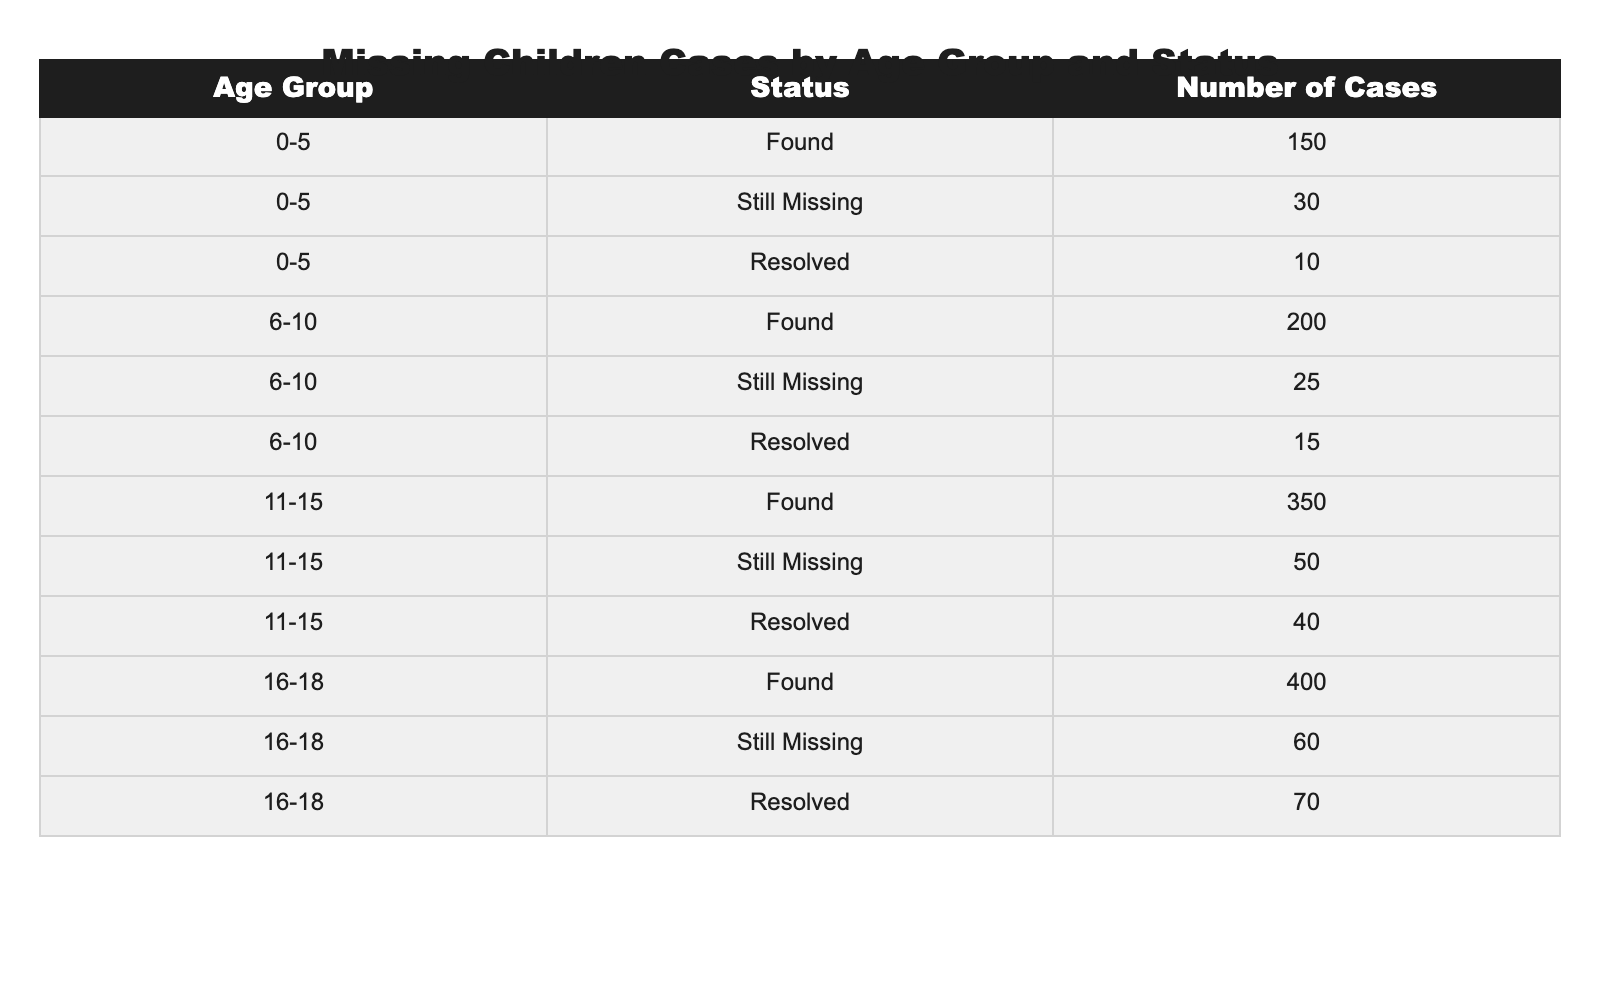What is the total number of missing children aged 0-5? To find this, I add the number of cases for the 'Still Missing' and 'Resolved' statuses for the 0-5 age group: 30 (Still Missing) + 10 (Resolved) = 40.
Answer: 40 How many children aged 11-15 are still missing? The table shows directly that there are 50 cases in the 'Still Missing' status for the 11-15 age group.
Answer: 50 What is the total number of found cases across all age groups? I add the number of cases for the 'Found' status in each age group: 150 (0-5) + 200 (6-10) + 350 (11-15) + 400 (16-18) = 1100.
Answer: 1100 Are there more found cases or missing cases in the age group 6-10? I compare the 'Found' cases (200) with the 'Still Missing' cases (25) in the 6-10 age group. Since 200 is greater than 25, there are more found cases.
Answer: Yes What is the average number of resolved cases across all age groups? I first find the total resolved cases: 10 (0-5) + 15 (6-10) + 40 (11-15) + 70 (16-18) = 135. There are 4 age groups, so the average is 135 / 4 = 33.75.
Answer: 33.75 Which age group has the highest number of still missing cases? The table shows: 30 (0-5), 25 (6-10), 50 (11-15), and 60 (16-18). The age group 16-18 has the highest with 60.
Answer: 16-18 How many more resolved cases are there in the 16-18 age group compared to the 0-5 age group? I subtract the resolved case number in the 0-5 age group (10) from the resolved case number in the 16-18 age group (70): 70 - 10 = 60.
Answer: 60 What is the total number of cases (found, still missing, resolved) for the age group 6-10? I sum up the cases: 200 (Found) + 25 (Still Missing) + 15 (Resolved) = 240 for the 6-10 age group.
Answer: 240 Is the number of missing children aged 16-18 greater than the number of resolved cases in the same age group? The number of still missing children aged 16-18 is 60, while resolved cases are 70. Since 60 is less than 70, the statement is false.
Answer: No Which age group has the lowest number of cases for 'Resolved'? The table shows: 10 (0-5), 15 (6-10), 40 (11-15), and 70 (16-18), so the age group 0-5 has the lowest with 10 'Resolved' cases.
Answer: 0-5 